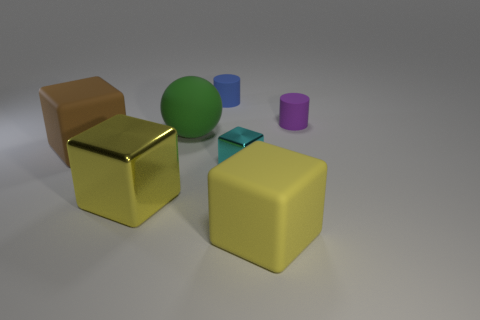There is another yellow object that is the same size as the yellow rubber thing; what is its material?
Your answer should be very brief. Metal. What number of other things are the same material as the brown object?
Provide a succinct answer. 4. The large rubber thing that is both right of the large metal thing and in front of the big ball is what color?
Give a very brief answer. Yellow. How many objects are small rubber cylinders behind the tiny purple matte object or metallic cubes?
Make the answer very short. 3. What number of other objects are there of the same color as the large shiny object?
Offer a terse response. 1. Is the number of spheres in front of the brown cube the same as the number of large brown metal things?
Provide a succinct answer. Yes. There is a matte block on the right side of the large matte cube to the left of the yellow rubber object; how many big yellow rubber objects are in front of it?
Your response must be concise. 0. There is a brown cube; is it the same size as the blue matte object that is behind the big matte ball?
Give a very brief answer. No. How many big yellow matte things are there?
Your response must be concise. 1. Do the matte block that is to the left of the green thing and the cylinder that is to the left of the small cyan metal thing have the same size?
Provide a short and direct response. No. 